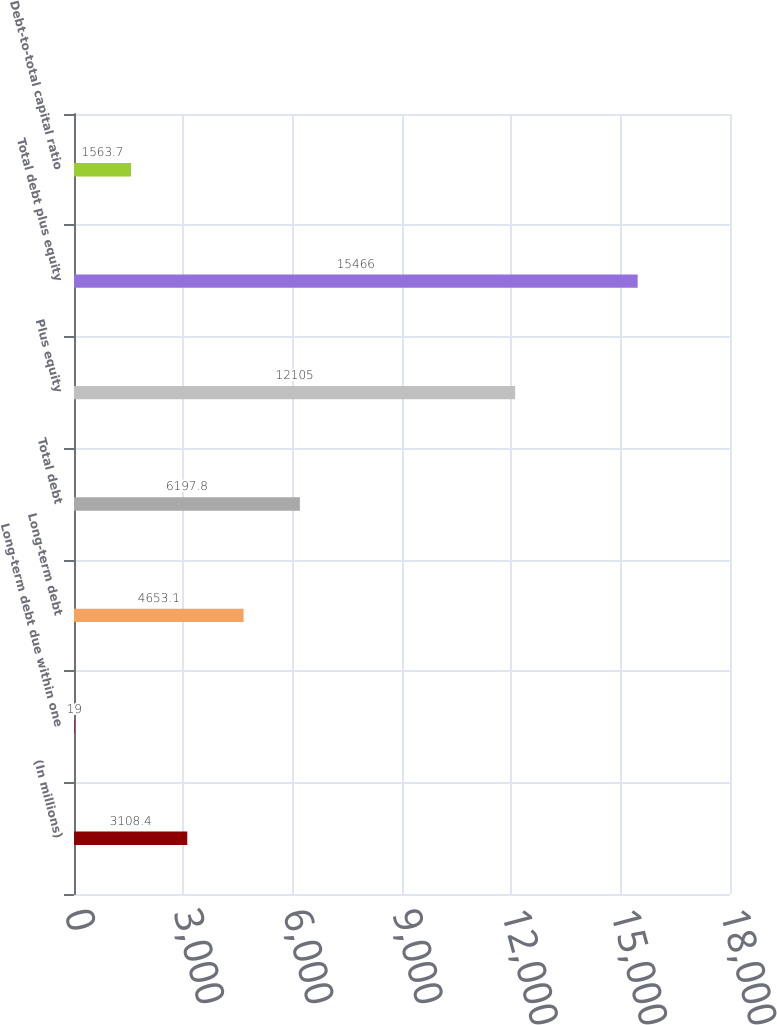<chart> <loc_0><loc_0><loc_500><loc_500><bar_chart><fcel>(In millions)<fcel>Long-term debt due within one<fcel>Long-term debt<fcel>Total debt<fcel>Plus equity<fcel>Total debt plus equity<fcel>Debt-to-total capital ratio<nl><fcel>3108.4<fcel>19<fcel>4653.1<fcel>6197.8<fcel>12105<fcel>15466<fcel>1563.7<nl></chart> 